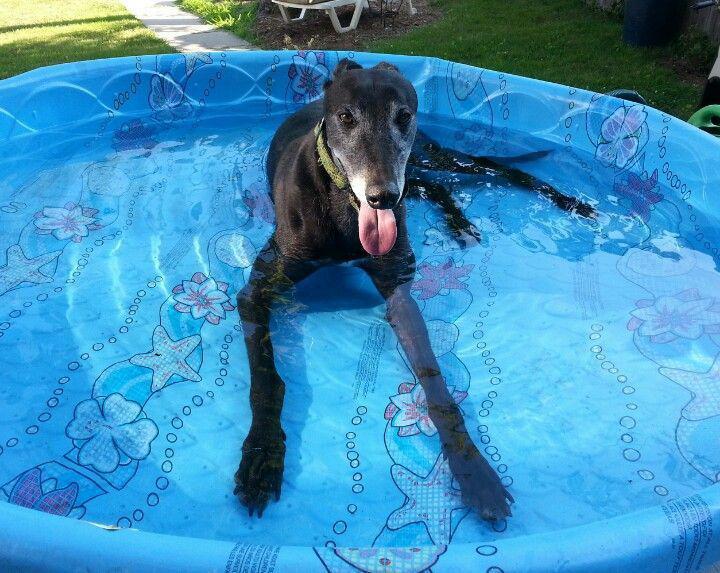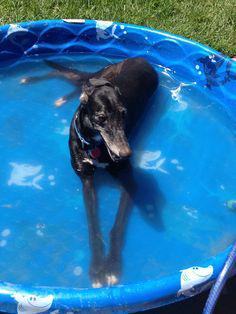The first image is the image on the left, the second image is the image on the right. Assess this claim about the two images: "there is a dog laying in a baby pool in the right image". Correct or not? Answer yes or no. Yes. The first image is the image on the left, the second image is the image on the right. Analyze the images presented: Is the assertion "At least one dog with dark fur is lying down in a small pool." valid? Answer yes or no. Yes. 